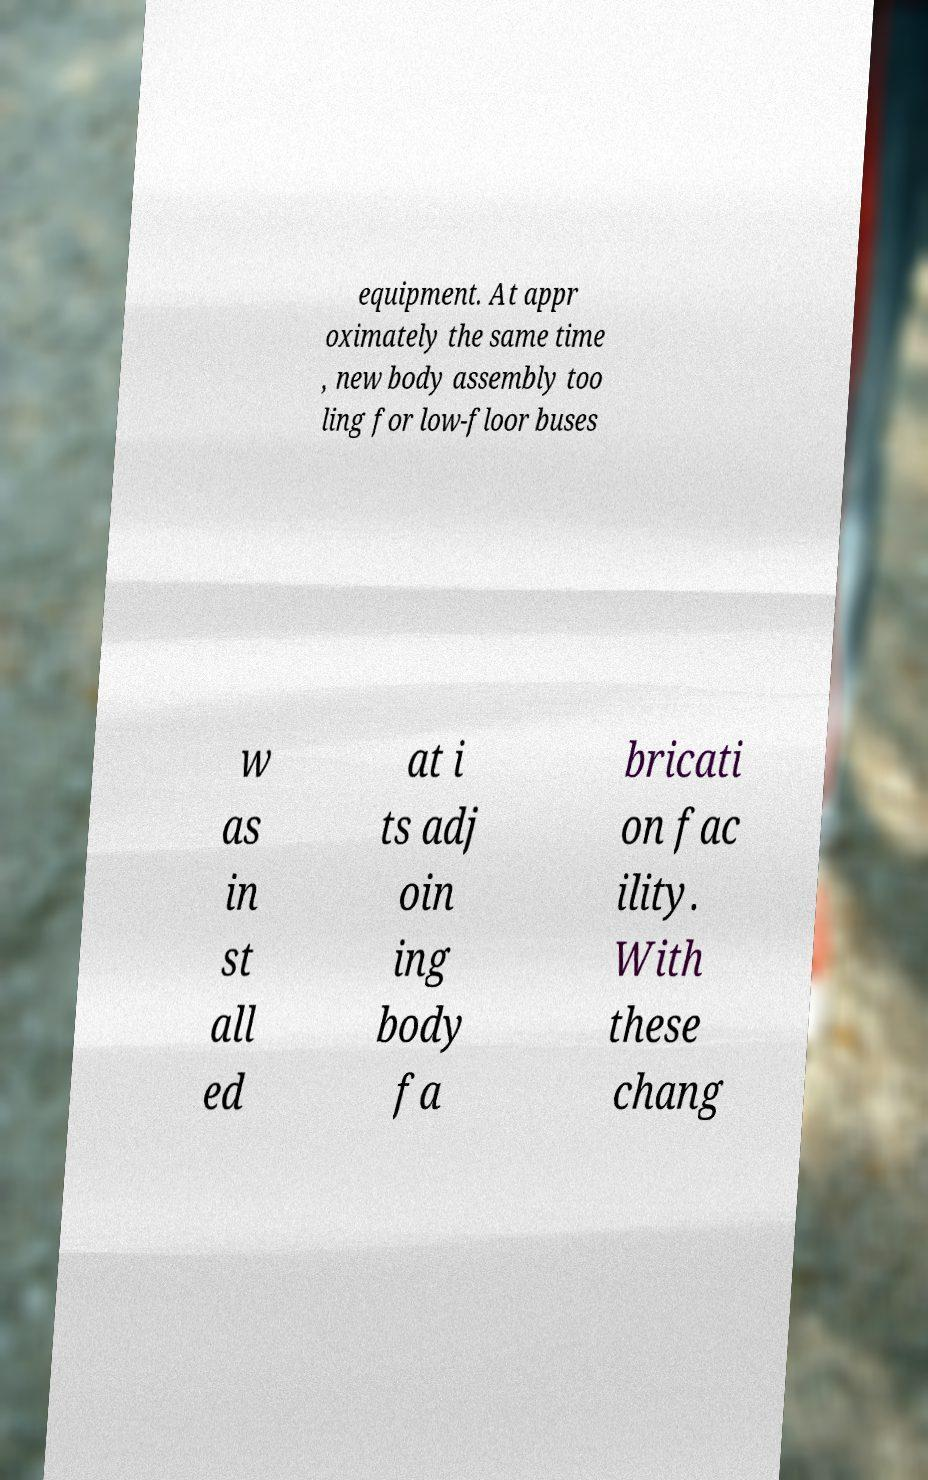For documentation purposes, I need the text within this image transcribed. Could you provide that? equipment. At appr oximately the same time , new body assembly too ling for low-floor buses w as in st all ed at i ts adj oin ing body fa bricati on fac ility. With these chang 